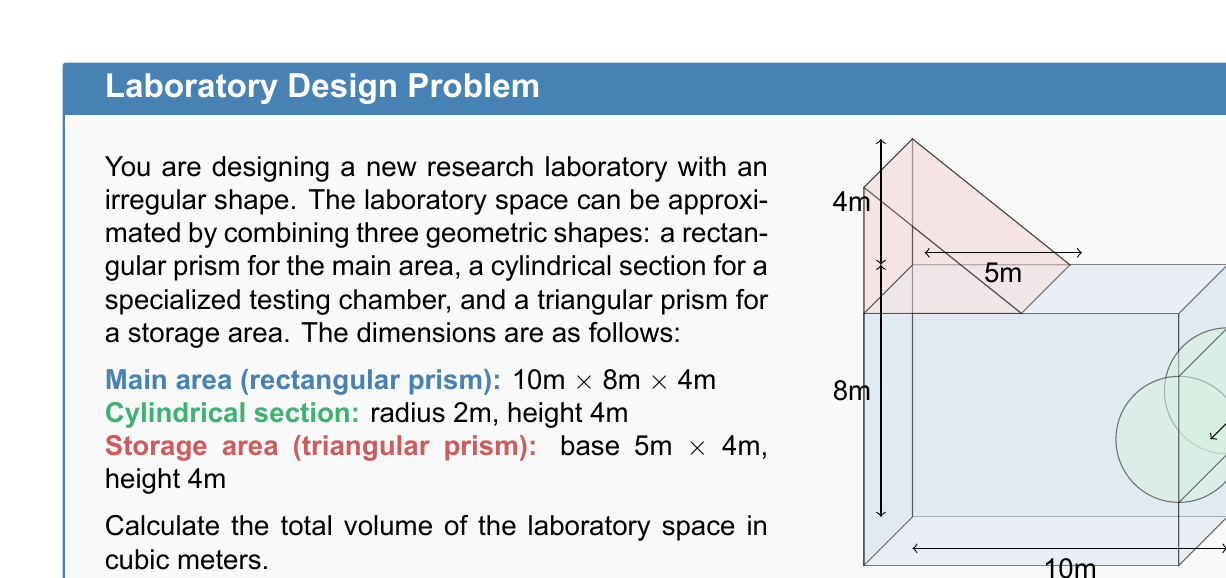Teach me how to tackle this problem. To calculate the total volume of the laboratory space, we need to sum the volumes of the three component shapes:

1. Volume of the main area (rectangular prism):
   $$V_1 = l \times w \times h = 10 \text{ m} \times 8 \text{ m} \times 4 \text{ m} = 320 \text{ m}^3$$

2. Volume of the cylindrical section:
   $$V_2 = \pi r^2 h = \pi \times (2 \text{ m})^2 \times 4 \text{ m} = 16\pi \text{ m}^3$$

3. Volume of the storage area (triangular prism):
   First, calculate the area of the triangular base:
   $$A_{base} = \frac{1}{2} \times 5 \text{ m} \times 4 \text{ m} = 10 \text{ m}^2$$
   Then, calculate the volume:
   $$V_3 = A_{base} \times h = 10 \text{ m}^2 \times 4 \text{ m} = 40 \text{ m}^3$$

Total volume:
$$V_{total} = V_1 + V_2 + V_3 = 320 \text{ m}^3 + 16\pi \text{ m}^3 + 40 \text{ m}^3 = (360 + 16\pi) \text{ m}^3$$

Approximating $\pi$ to two decimal places (3.14):
$$(360 + 16 \times 3.14) \text{ m}^3 = (360 + 50.24) \text{ m}^3 = 410.24 \text{ m}^3$$
Answer: 410.24 m³ 